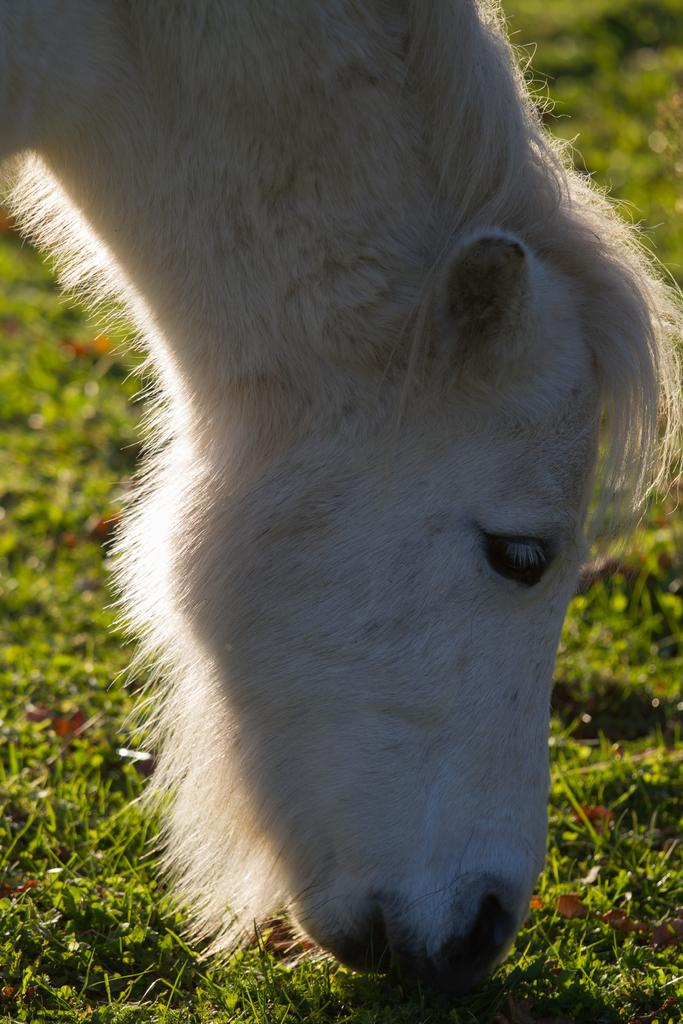What type of animal can be seen in the image? There is an animal in the image, but its specific type cannot be determined from the provided facts. What color is the animal in the image? The animal is white in color. What is the ground covered with in the image? There is grass on the ground in the image. What type of stocking is the animal wearing in the image? There is no mention of stockings or any clothing on the animal in the image. What type of skin condition does the animal have in the image? There is no information about the animal's skin condition in the image. 